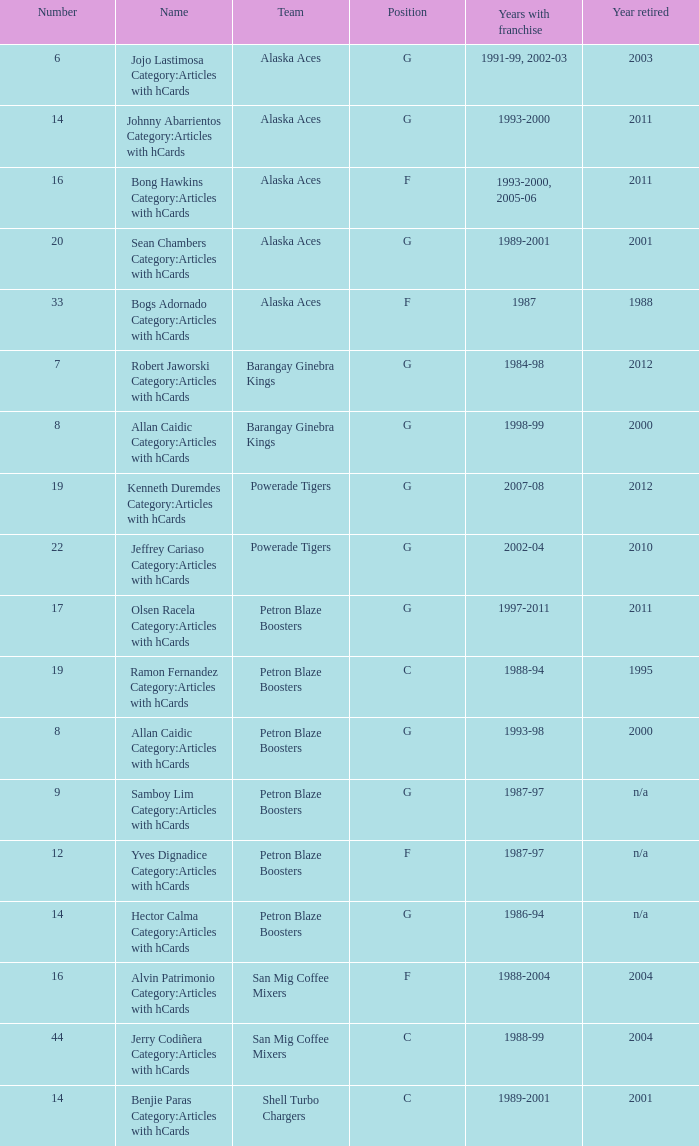How many years did the team in slot number 9 have a franchise? 1987-97. 